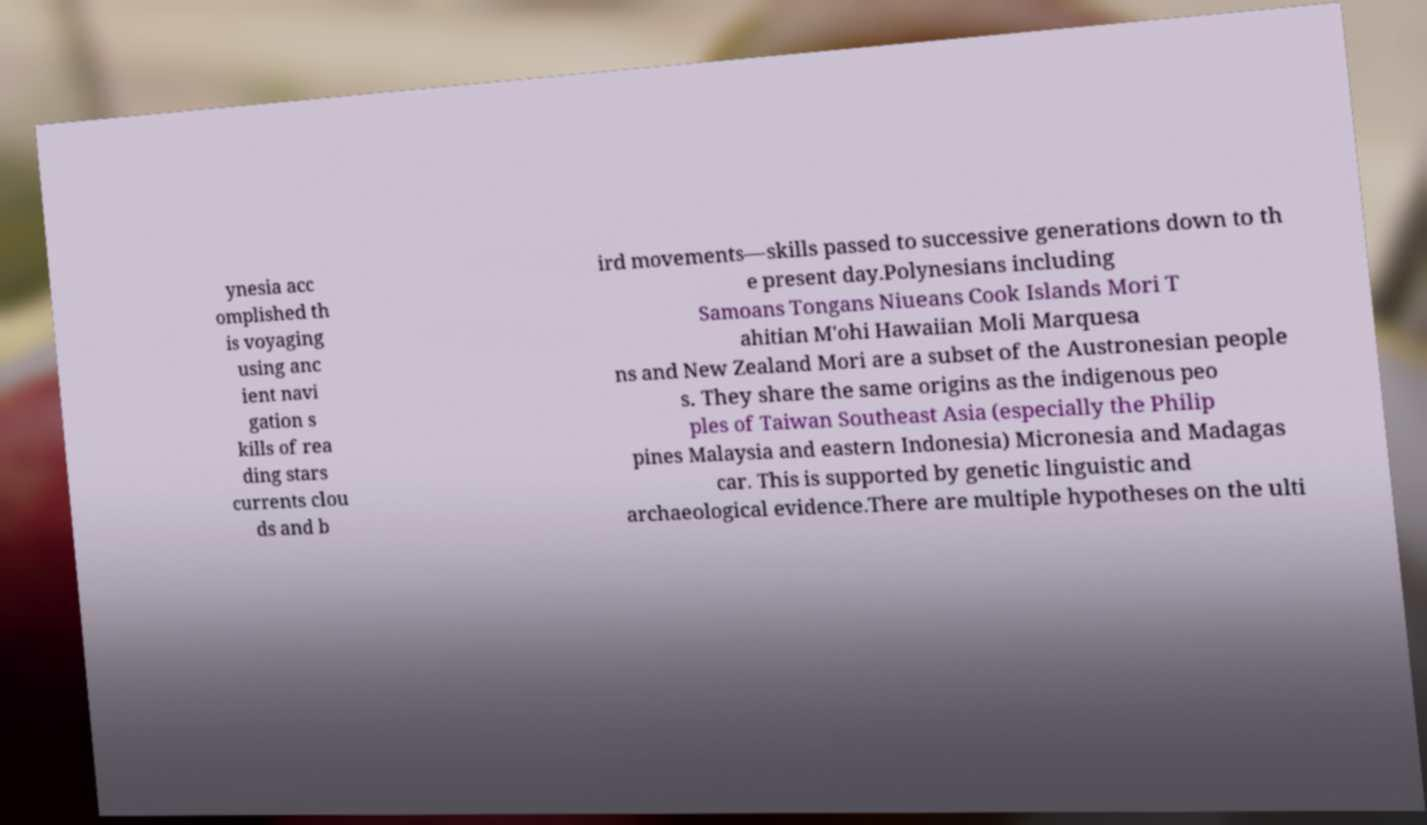Please read and relay the text visible in this image. What does it say? ynesia acc omplished th is voyaging using anc ient navi gation s kills of rea ding stars currents clou ds and b ird movements—skills passed to successive generations down to th e present day.Polynesians including Samoans Tongans Niueans Cook Islands Mori T ahitian M'ohi Hawaiian Moli Marquesa ns and New Zealand Mori are a subset of the Austronesian people s. They share the same origins as the indigenous peo ples of Taiwan Southeast Asia (especially the Philip pines Malaysia and eastern Indonesia) Micronesia and Madagas car. This is supported by genetic linguistic and archaeological evidence.There are multiple hypotheses on the ulti 